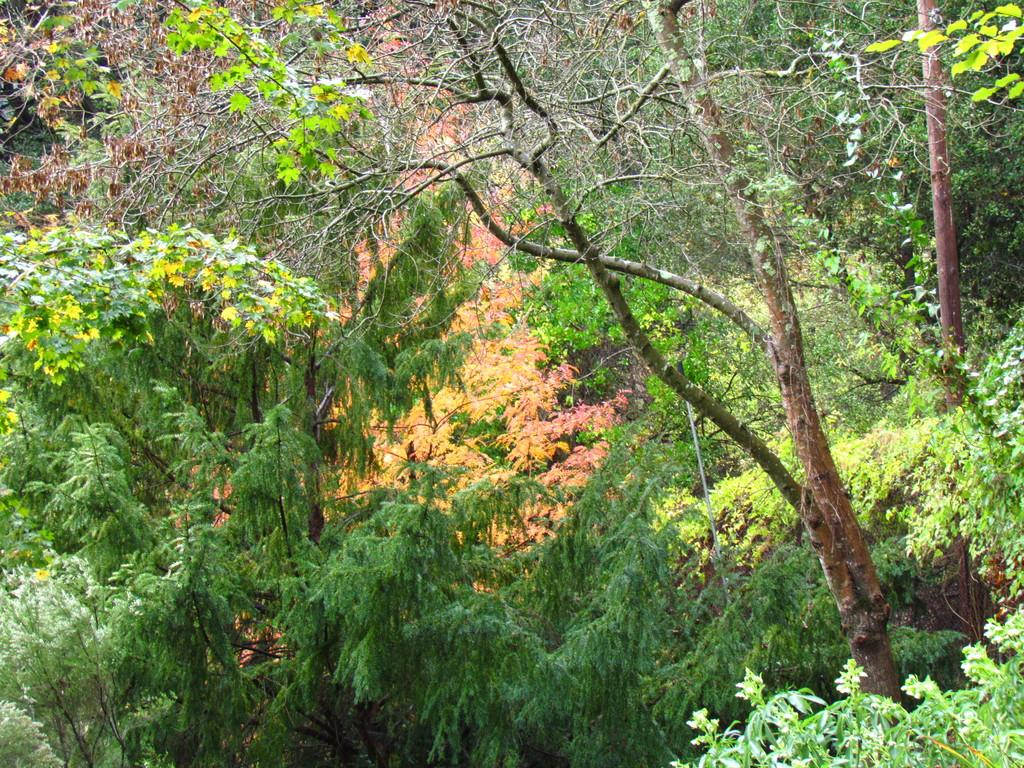Where was the image taken? The image was taken outdoors. What can be seen in the background of the image? There are many trees in the image. What type of brain can be seen in the image? There is no brain present in the image; it features an outdoor scene with many trees. What kind of drum is visible in the image? There is no drum present in the image; it features an outdoor scene with many trees. 